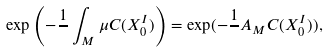<formula> <loc_0><loc_0><loc_500><loc_500>\exp \left ( - \frac { 1 } { } \int _ { M } \mu C ( X _ { 0 } ^ { I } ) \right ) = \exp ( - \frac { 1 } { } A _ { M } C ( X _ { 0 } ^ { I } ) ) ,</formula> 